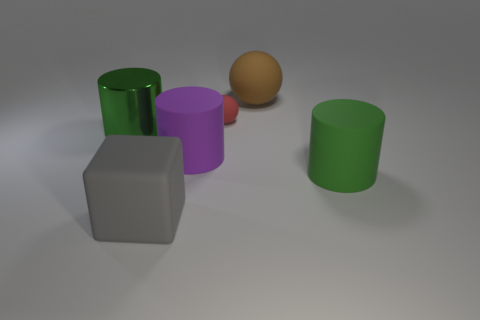Add 1 matte balls. How many objects exist? 7 Subtract all balls. How many objects are left? 4 Add 5 matte balls. How many matte balls are left? 7 Add 1 brown matte balls. How many brown matte balls exist? 2 Subtract 0 green spheres. How many objects are left? 6 Subtract all matte things. Subtract all small rubber spheres. How many objects are left? 0 